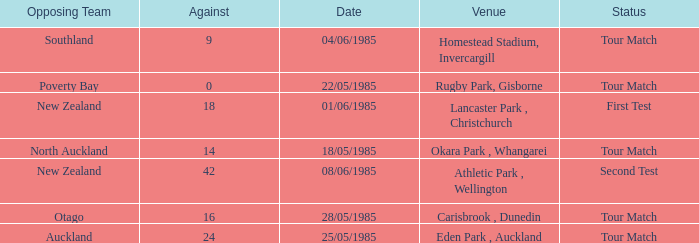Which venue had an against score smaller than 18 when the opposing team was North Auckland? Okara Park , Whangarei. 